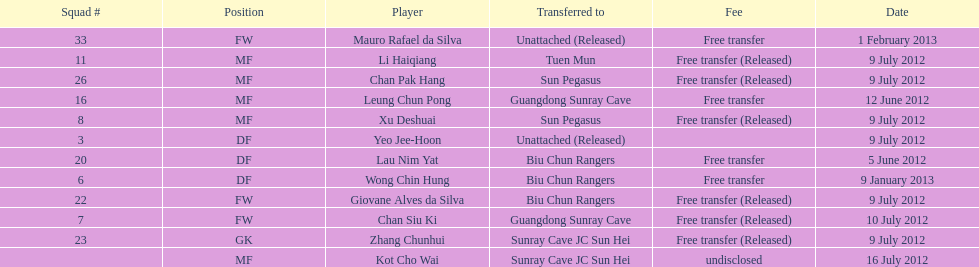To which team were lau nim yat and giovane alves de silva both transferred? Biu Chun Rangers. 